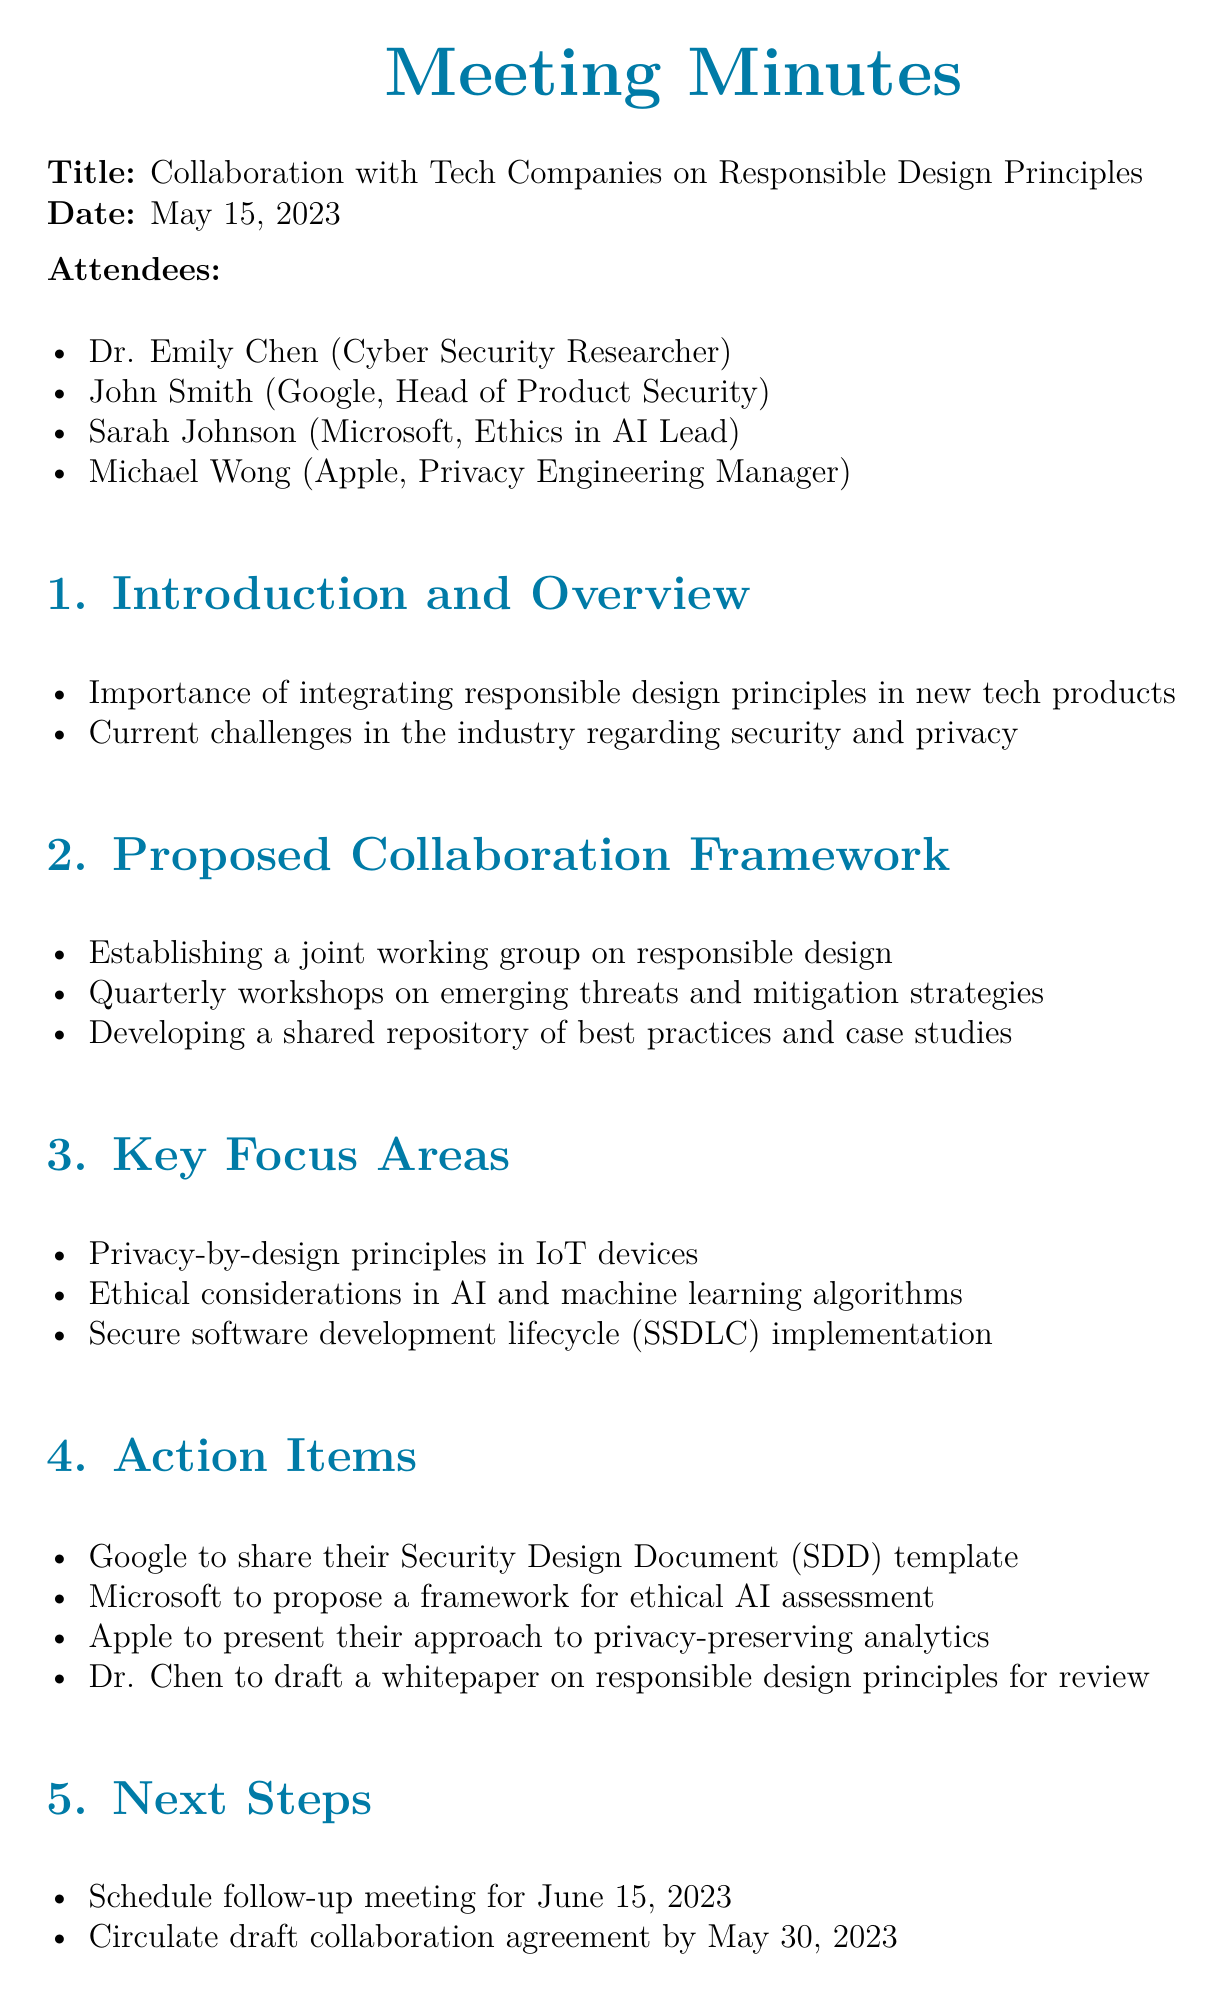What is the meeting title? The document states the title of the meeting as "Collaboration with Tech Companies on Responsible Design Principles."
Answer: Collaboration with Tech Companies on Responsible Design Principles Who is the Ethics in AI Lead from Microsoft? The document lists Sarah Johnson as the Ethics in AI Lead from Microsoft.
Answer: Sarah Johnson What date is the follow-up meeting scheduled for? The follow-up meeting is scheduled for June 15, 2023, as mentioned in the Next Steps section.
Answer: June 15, 2023 What is one of the key focus areas discussed in the meeting? The document mentions "Privacy-by-design principles in IoT devices" as one of the key focus areas.
Answer: Privacy-by-design principles in IoT devices Which company is responsible for drafting a whitepaper on responsible design principles? Dr. Chen is tasked with drafting a whitepaper on responsible design principles for review.
Answer: Dr. Chen What is a proposed action item for Google? The document specifies that Google will share their Security Design Document (SDD) template.
Answer: Share their Security Design Document (SDD) template What does the proposed collaboration framework include? The framework includes establishing a joint working group on responsible design.
Answer: Establishing a joint working group on responsible design Which organization is tasked to propose a framework for ethical AI assessment? Microsoft is assigned to propose a framework for ethical AI assessment.
Answer: Microsoft 